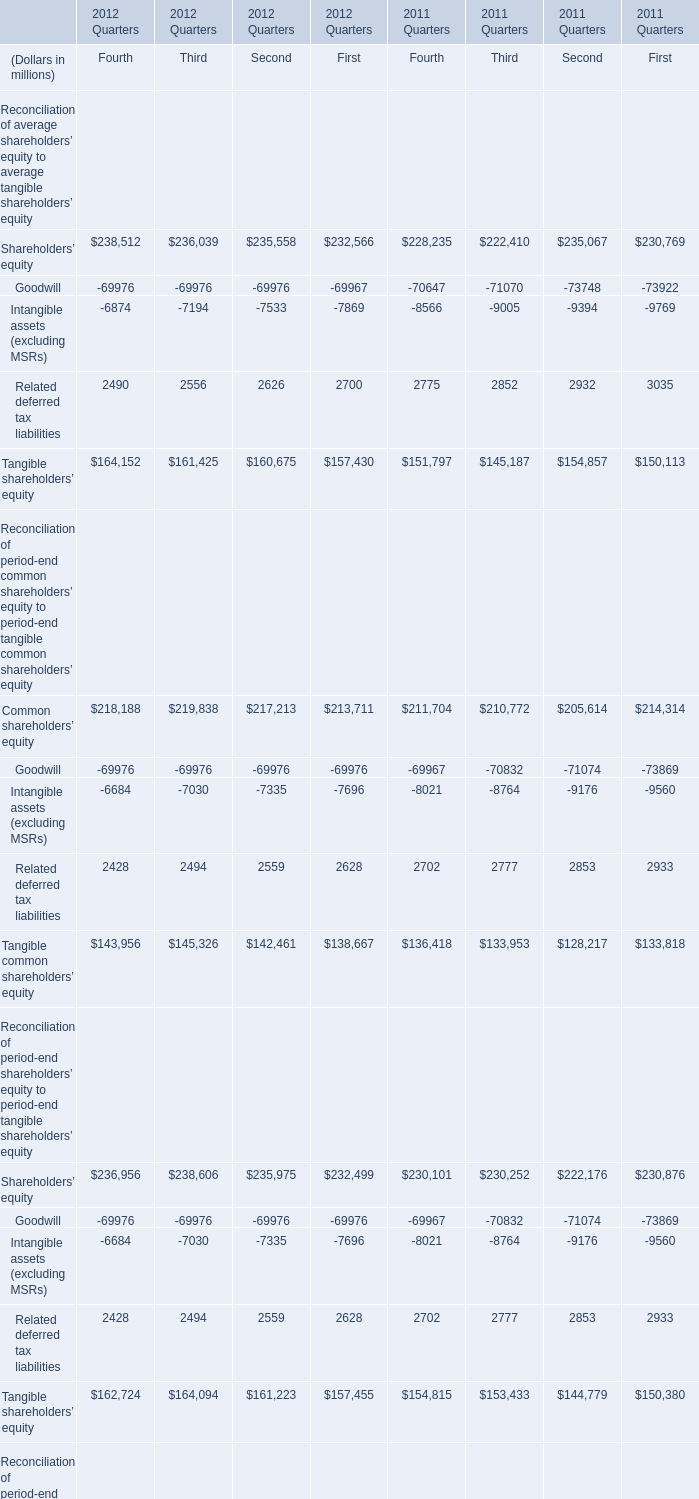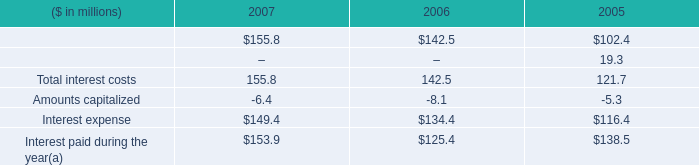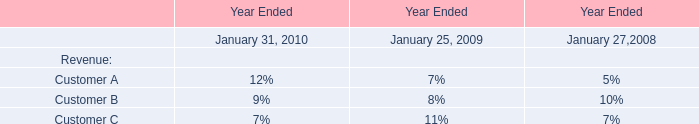what are the expected annual cash interest costs for the 6.625% ( 6.625 % ) senior notes? 
Computations: ((450 * 1000000) * 6.625%)
Answer: 29812500.0. 